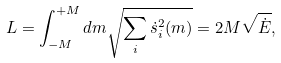Convert formula to latex. <formula><loc_0><loc_0><loc_500><loc_500>L = \int _ { - M } ^ { + M } d m \sqrt { \sum _ { i } \dot { s } _ { i } ^ { 2 } ( m ) } = 2 M \sqrt { \dot { E } } ,</formula> 